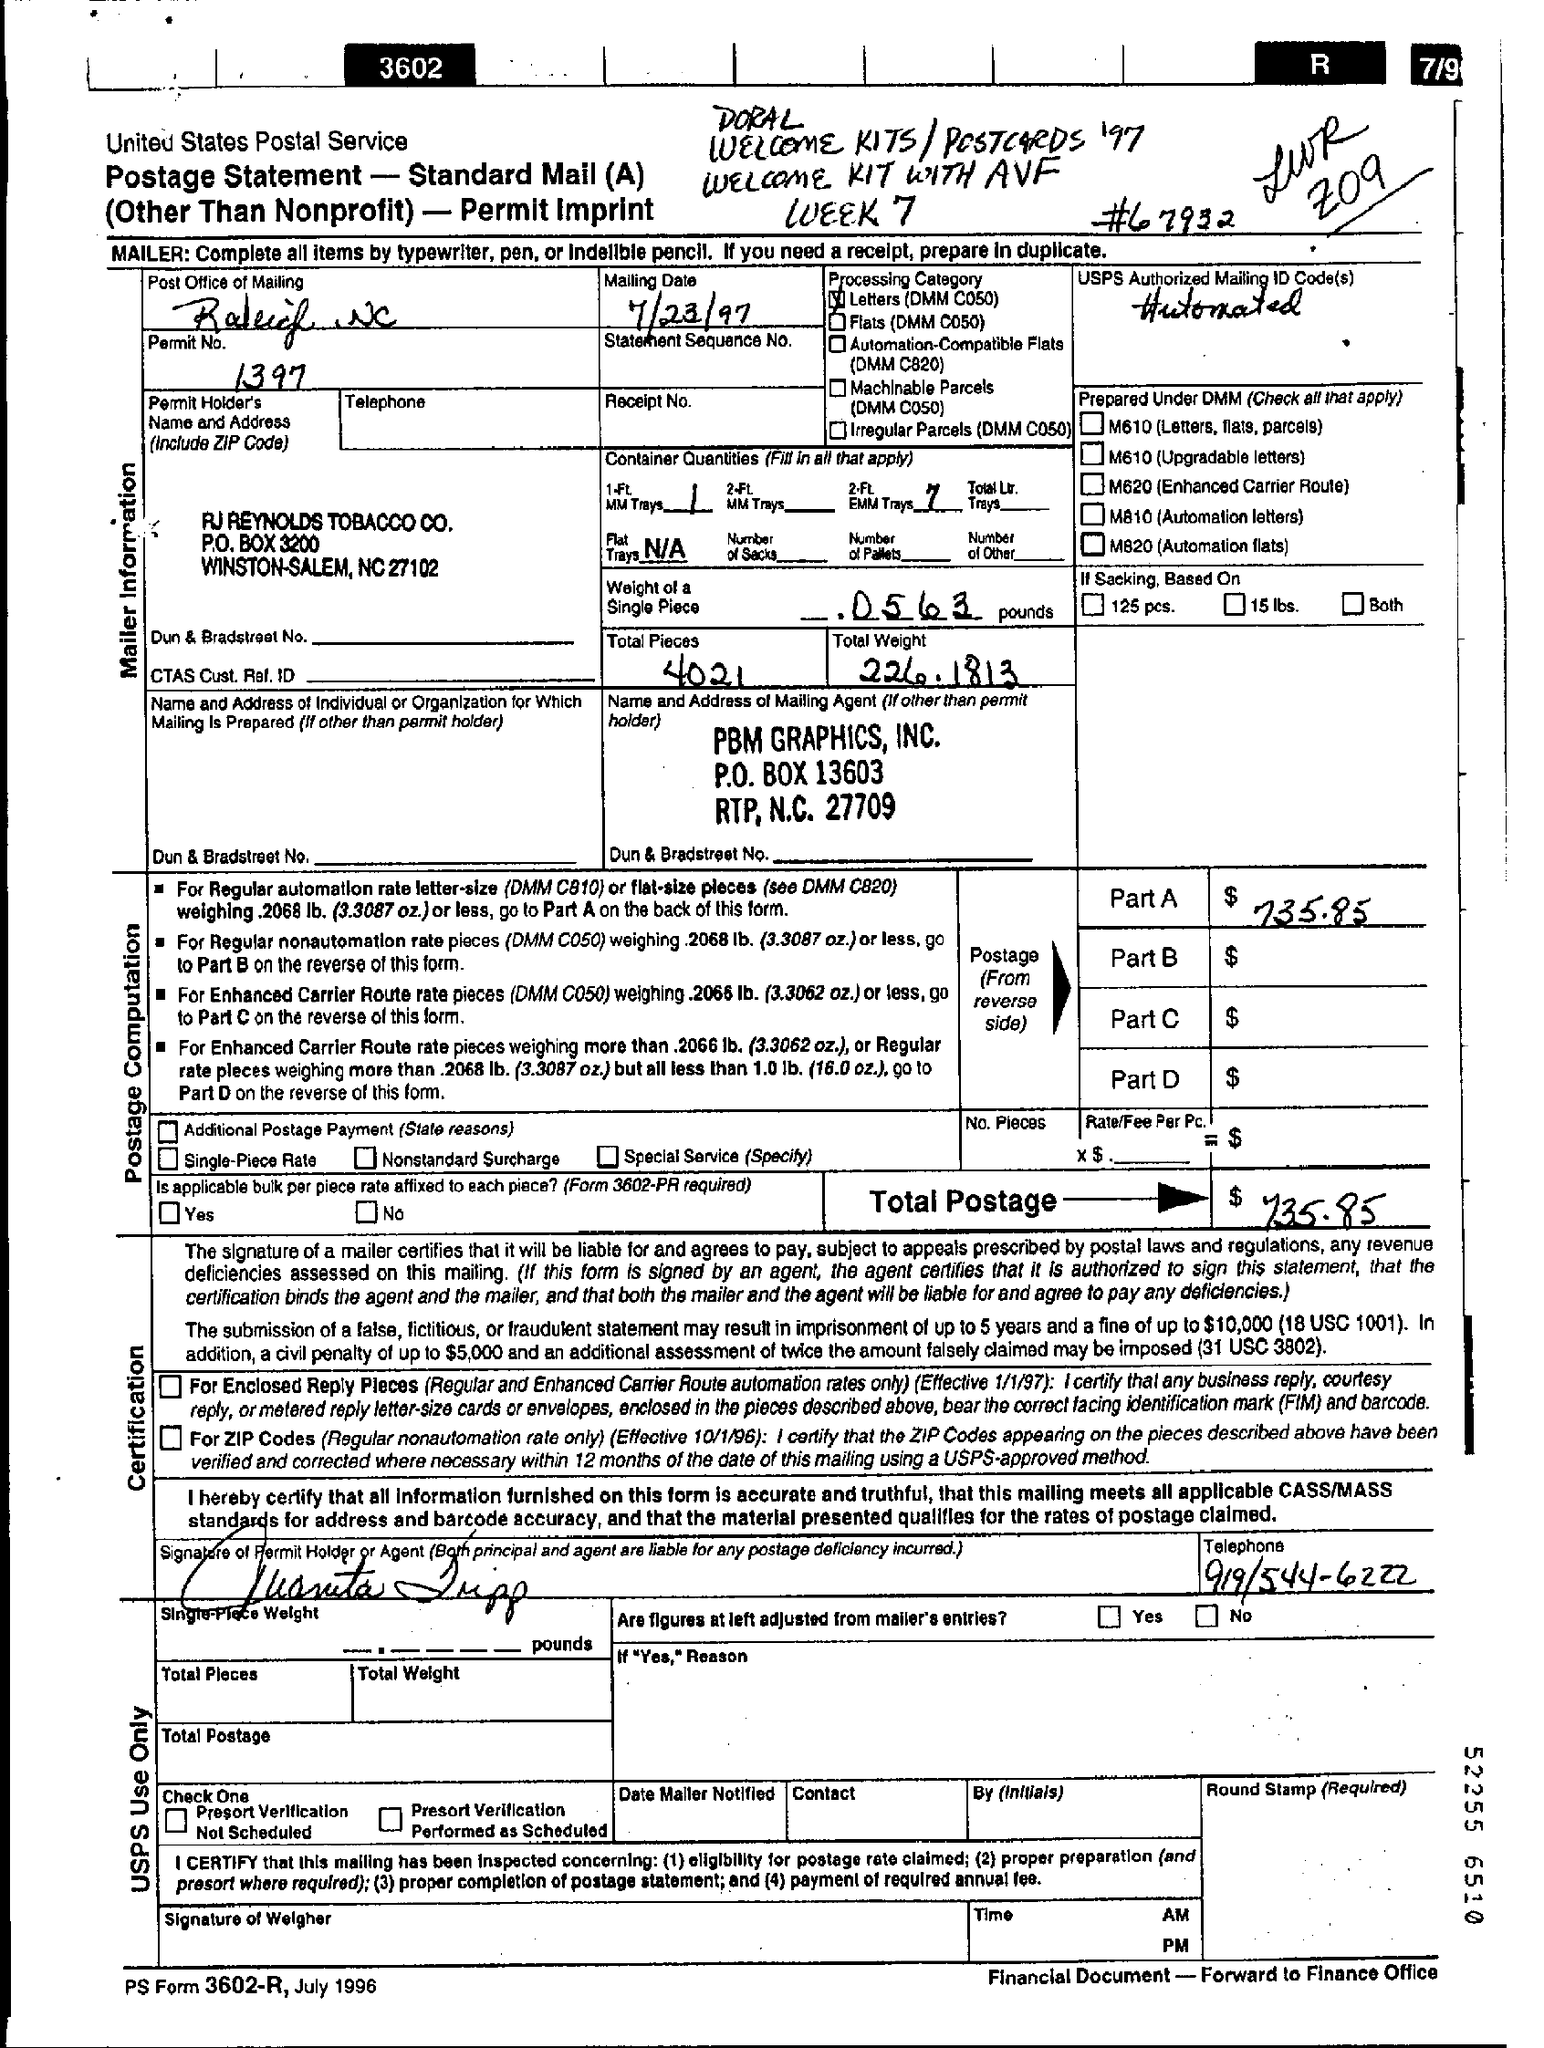What is the Mailing Date?
Offer a terse response. 7/23/97. What is the Permit No.?
Your answer should be compact. 1397. What is the Weight of a single piece?
Provide a succinct answer. .0563 pounds. What is the Total Pieces?
Your answer should be very brief. 4021. What is the Total Weight?
Offer a terse response. 226.1813. What is the Total Postage?
Provide a succinct answer. 735.85. 